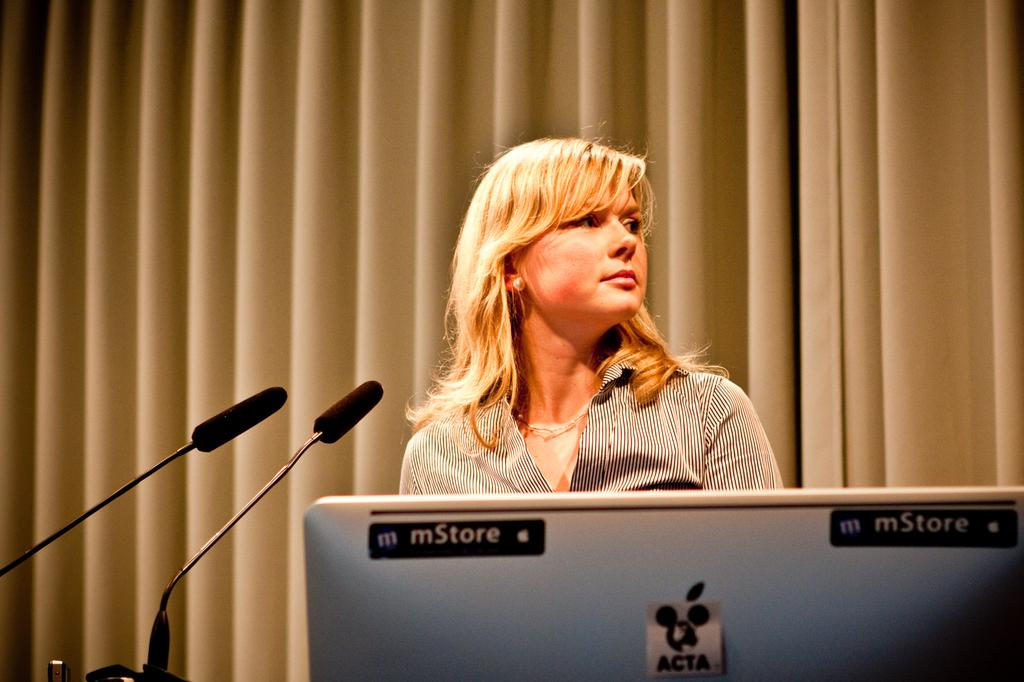Who is present in the image? There is a woman in the image. What objects can be seen in the image? There are microphones in the image. What type of covering is present on the backside of the image? There is a curtain on the backside in the image. What type of stick can be seen in the woman's hand in the image? There is no stick present in the woman's hand or in the image. 